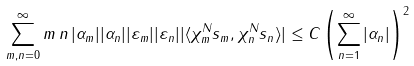<formula> <loc_0><loc_0><loc_500><loc_500>& \sum _ { m , n = 0 } ^ { \infty } m \, n \, | \alpha _ { m } | | \alpha _ { n } | | \varepsilon _ { m } | | \varepsilon _ { n } | | \langle \chi _ { m } ^ { N } s _ { m } , \chi _ { n } ^ { N } s _ { n } \rangle | \leq C \left ( \sum _ { n = 1 } ^ { \infty } | \alpha _ { n } | \right ) ^ { 2 } \\</formula> 